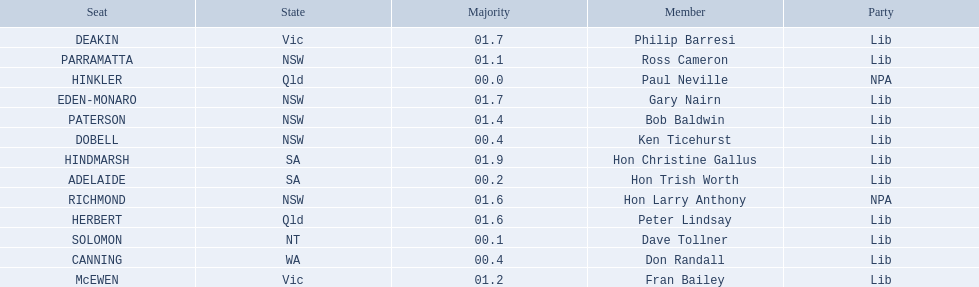What state does hinkler belong too? Qld. What is the majority of difference between sa and qld? 01.9. 